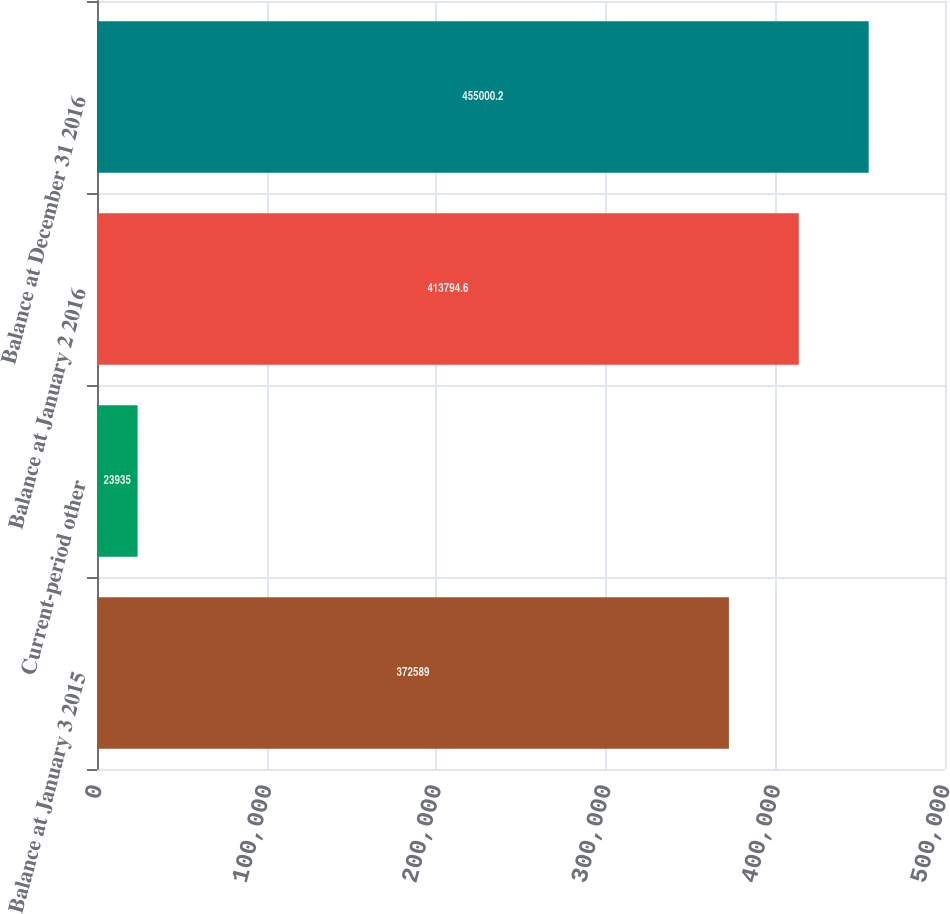<chart> <loc_0><loc_0><loc_500><loc_500><bar_chart><fcel>Balance at January 3 2015<fcel>Current-period other<fcel>Balance at January 2 2016<fcel>Balance at December 31 2016<nl><fcel>372589<fcel>23935<fcel>413795<fcel>455000<nl></chart> 